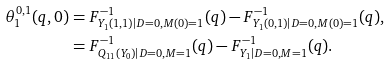<formula> <loc_0><loc_0><loc_500><loc_500>\theta _ { 1 } ^ { 0 , 1 } ( q , 0 ) & = F _ { Y _ { 1 } ( 1 , 1 ) | D = 0 , M ( 0 ) = 1 } ^ { - 1 } ( q ) - F _ { Y _ { 1 } ( 0 , 1 ) | D = 0 , M ( 0 ) = 1 } ^ { - 1 } ( q ) , \\ & = F _ { Q _ { 1 1 } ( Y _ { 0 } ) | D = 0 , M = 1 } ^ { - 1 } ( q ) - F _ { Y _ { 1 } | D = 0 , M = 1 } ^ { - 1 } ( q ) .</formula> 